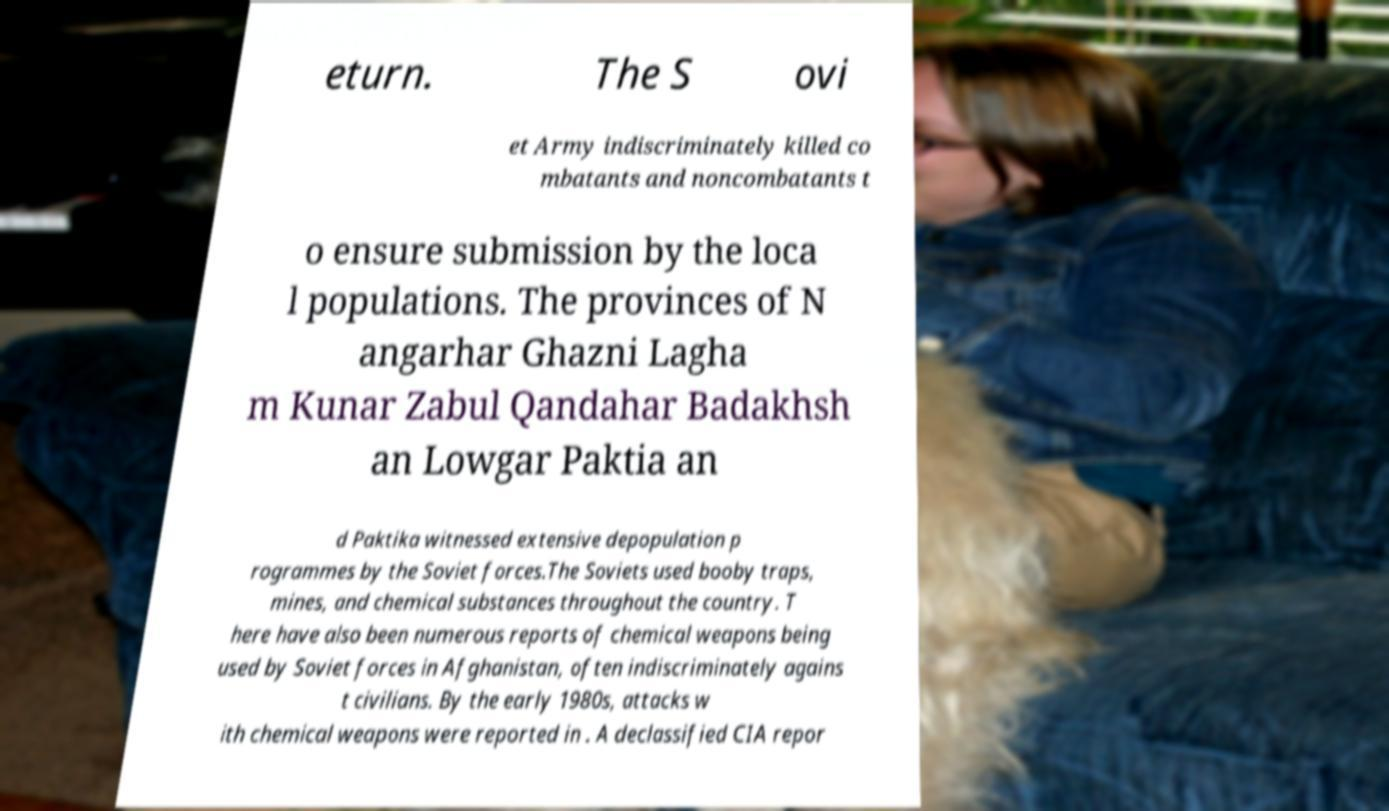Please identify and transcribe the text found in this image. eturn. The S ovi et Army indiscriminately killed co mbatants and noncombatants t o ensure submission by the loca l populations. The provinces of N angarhar Ghazni Lagha m Kunar Zabul Qandahar Badakhsh an Lowgar Paktia an d Paktika witnessed extensive depopulation p rogrammes by the Soviet forces.The Soviets used booby traps, mines, and chemical substances throughout the country. T here have also been numerous reports of chemical weapons being used by Soviet forces in Afghanistan, often indiscriminately agains t civilians. By the early 1980s, attacks w ith chemical weapons were reported in . A declassified CIA repor 